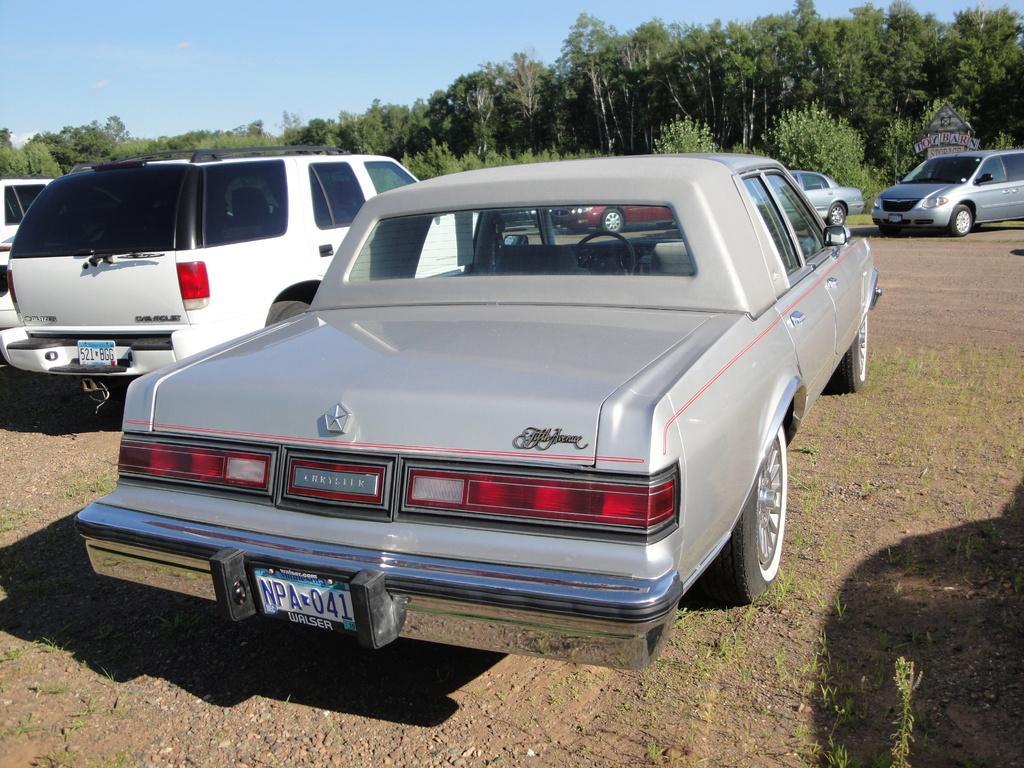Can you describe this image briefly? In this image, there are cars on the ground. On the right side of the image, I can see a board. In the background, there are trees and the sky. 